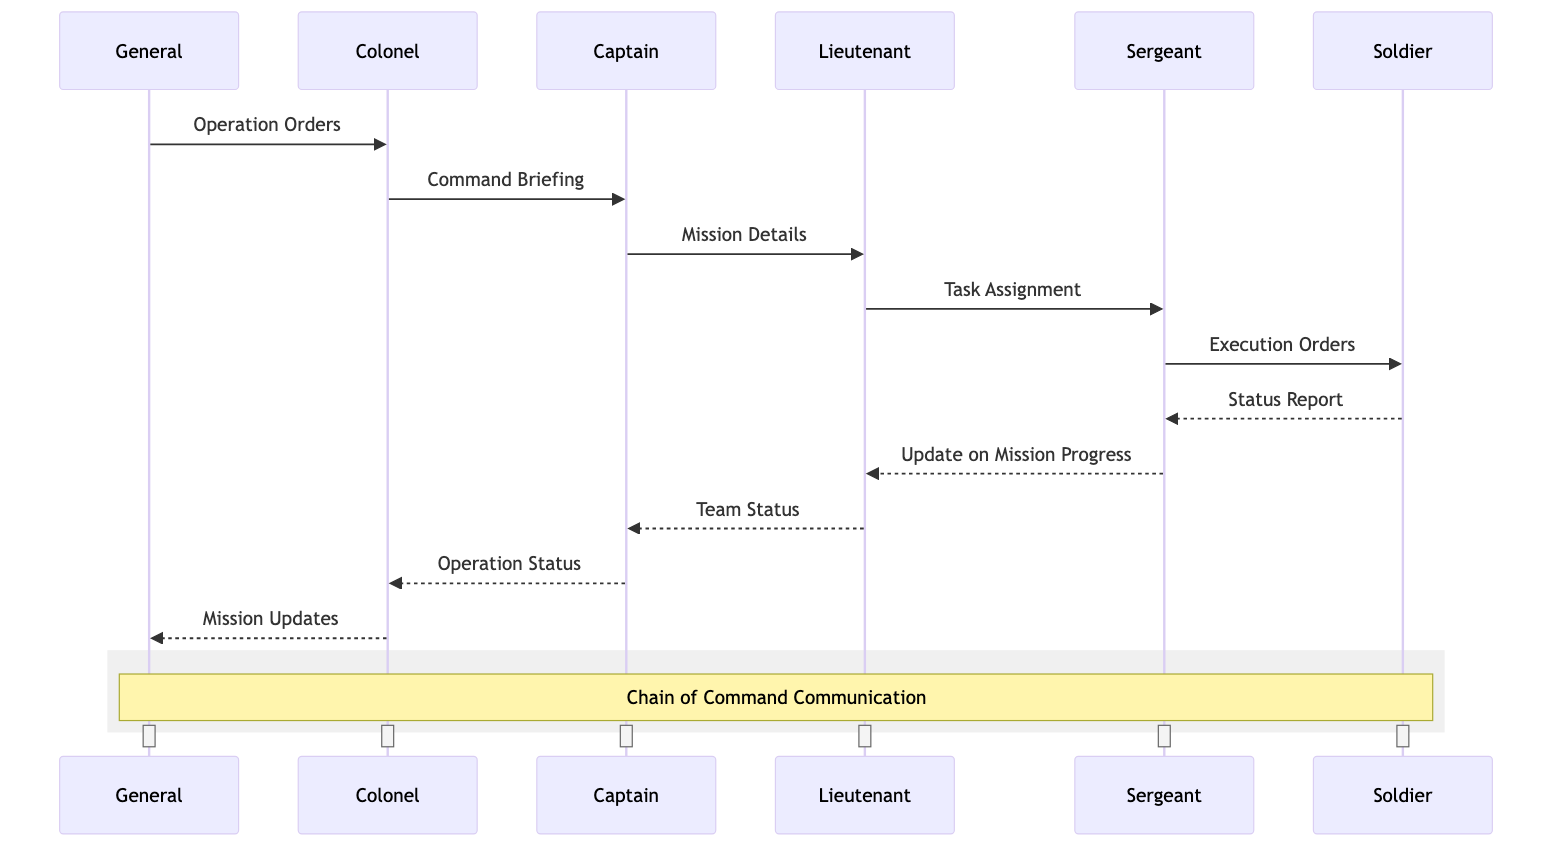What is the first message sent in the sequence? The first message sent is "Operation Orders" from the General to the Colonel. This can be identified as the first line in the sequence of communication in the diagram.
Answer: Operation Orders How many participants are involved in the communication? The diagram shows six participants: General, Colonel, Captain, Lieutenant, Sergeant, and Soldier. Counting each one gives the total number of participants.
Answer: Six Who receives the "Command Briefing"? The "Command Briefing" is sent from the Colonel to the Captain. This is directly shown in the second message of the sequence.
Answer: Captain How many messages are sent from the Sergeant? The Sergeant sends two messages: "Execution Orders" to the Soldier and "Update on Mission Progress" to the Lieutenant. Counting these messages leads to the answer.
Answer: Two Which participant sends the last message in the sequence? The last message in the sequence is "Mission Updates" sent from the Colonel to the General, as noted at the end of the diagram flow.
Answer: Colonel What is the purpose of the message sent from the Lieutenant to the Captain? The message sent from the Lieutenant to the Captain is "Team Status," which serves the purpose of updating the Captain on the team's condition, reflecting the chain of command.
Answer: Team Status Which message indicates the task assignment? The message indicating the task assignment is "Task Assignment," sent from the Lieutenant to the Sergeant. This step in the communication confirms the specific duties assigned.
Answer: Task Assignment Explain the flow from Sergeant to Soldier. The flow from Sergeant to Soldier begins with the Sergeant sending "Execution Orders" to the Soldier. Following that, the Soldier responds with a "Status Report" back to the Sergeant. This direct interaction ensures that orders are issued and feedback on execution is reported.
Answer: Execution Orders, Status Report What is encapsulated in the note over the diagram? The note encapsulated in the diagram states "Chain of Command Communication." This note describes the overall function and purpose of the entire sequence of messages and interactions shown.
Answer: Chain of Command Communication 